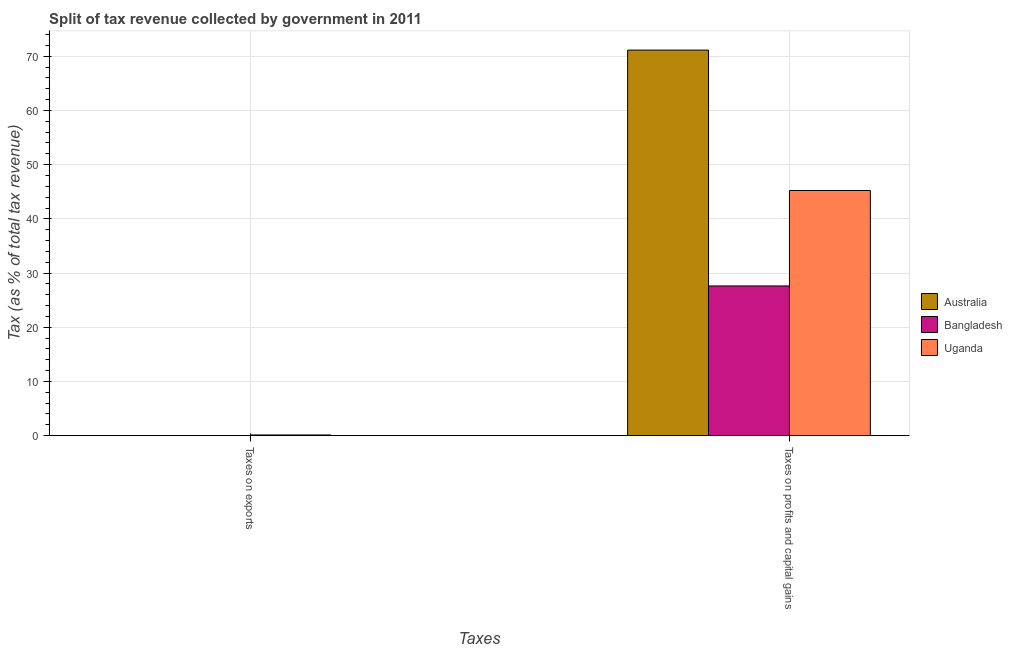How many groups of bars are there?
Give a very brief answer. 2. Are the number of bars on each tick of the X-axis equal?
Give a very brief answer. Yes. What is the label of the 2nd group of bars from the left?
Your answer should be very brief. Taxes on profits and capital gains. What is the percentage of revenue obtained from taxes on profits and capital gains in Uganda?
Your answer should be compact. 45.24. Across all countries, what is the maximum percentage of revenue obtained from taxes on profits and capital gains?
Offer a very short reply. 71.14. Across all countries, what is the minimum percentage of revenue obtained from taxes on profits and capital gains?
Make the answer very short. 27.62. In which country was the percentage of revenue obtained from taxes on profits and capital gains minimum?
Make the answer very short. Bangladesh. What is the total percentage of revenue obtained from taxes on profits and capital gains in the graph?
Offer a terse response. 143.99. What is the difference between the percentage of revenue obtained from taxes on profits and capital gains in Australia and that in Uganda?
Offer a terse response. 25.9. What is the difference between the percentage of revenue obtained from taxes on profits and capital gains in Uganda and the percentage of revenue obtained from taxes on exports in Bangladesh?
Keep it short and to the point. 45.24. What is the average percentage of revenue obtained from taxes on profits and capital gains per country?
Offer a terse response. 48. What is the difference between the percentage of revenue obtained from taxes on profits and capital gains and percentage of revenue obtained from taxes on exports in Australia?
Provide a short and direct response. 71.13. In how many countries, is the percentage of revenue obtained from taxes on profits and capital gains greater than 22 %?
Ensure brevity in your answer.  3. What is the ratio of the percentage of revenue obtained from taxes on exports in Bangladesh to that in Australia?
Offer a very short reply. 0. What does the 3rd bar from the left in Taxes on profits and capital gains represents?
Give a very brief answer. Uganda. What does the 1st bar from the right in Taxes on profits and capital gains represents?
Make the answer very short. Uganda. Are all the bars in the graph horizontal?
Offer a terse response. No. How many countries are there in the graph?
Your answer should be compact. 3. Are the values on the major ticks of Y-axis written in scientific E-notation?
Make the answer very short. No. Does the graph contain grids?
Ensure brevity in your answer.  Yes. Where does the legend appear in the graph?
Your answer should be very brief. Center right. How many legend labels are there?
Offer a terse response. 3. How are the legend labels stacked?
Your answer should be very brief. Vertical. What is the title of the graph?
Provide a succinct answer. Split of tax revenue collected by government in 2011. Does "Nigeria" appear as one of the legend labels in the graph?
Offer a very short reply. No. What is the label or title of the X-axis?
Offer a terse response. Taxes. What is the label or title of the Y-axis?
Your answer should be compact. Tax (as % of total tax revenue). What is the Tax (as % of total tax revenue) of Australia in Taxes on exports?
Provide a short and direct response. 0. What is the Tax (as % of total tax revenue) in Bangladesh in Taxes on exports?
Provide a succinct answer. 1.00567926439932e-6. What is the Tax (as % of total tax revenue) in Uganda in Taxes on exports?
Your response must be concise. 0.13. What is the Tax (as % of total tax revenue) in Australia in Taxes on profits and capital gains?
Make the answer very short. 71.14. What is the Tax (as % of total tax revenue) in Bangladesh in Taxes on profits and capital gains?
Keep it short and to the point. 27.62. What is the Tax (as % of total tax revenue) of Uganda in Taxes on profits and capital gains?
Provide a succinct answer. 45.24. Across all Taxes, what is the maximum Tax (as % of total tax revenue) in Australia?
Give a very brief answer. 71.14. Across all Taxes, what is the maximum Tax (as % of total tax revenue) of Bangladesh?
Your response must be concise. 27.62. Across all Taxes, what is the maximum Tax (as % of total tax revenue) in Uganda?
Keep it short and to the point. 45.24. Across all Taxes, what is the minimum Tax (as % of total tax revenue) in Australia?
Provide a succinct answer. 0. Across all Taxes, what is the minimum Tax (as % of total tax revenue) in Bangladesh?
Ensure brevity in your answer.  1.00567926439932e-6. Across all Taxes, what is the minimum Tax (as % of total tax revenue) in Uganda?
Your answer should be very brief. 0.13. What is the total Tax (as % of total tax revenue) in Australia in the graph?
Your answer should be very brief. 71.14. What is the total Tax (as % of total tax revenue) of Bangladesh in the graph?
Ensure brevity in your answer.  27.62. What is the total Tax (as % of total tax revenue) in Uganda in the graph?
Your answer should be very brief. 45.36. What is the difference between the Tax (as % of total tax revenue) in Australia in Taxes on exports and that in Taxes on profits and capital gains?
Make the answer very short. -71.13. What is the difference between the Tax (as % of total tax revenue) in Bangladesh in Taxes on exports and that in Taxes on profits and capital gains?
Offer a terse response. -27.62. What is the difference between the Tax (as % of total tax revenue) in Uganda in Taxes on exports and that in Taxes on profits and capital gains?
Offer a terse response. -45.11. What is the difference between the Tax (as % of total tax revenue) of Australia in Taxes on exports and the Tax (as % of total tax revenue) of Bangladesh in Taxes on profits and capital gains?
Give a very brief answer. -27.62. What is the difference between the Tax (as % of total tax revenue) of Australia in Taxes on exports and the Tax (as % of total tax revenue) of Uganda in Taxes on profits and capital gains?
Your response must be concise. -45.23. What is the difference between the Tax (as % of total tax revenue) in Bangladesh in Taxes on exports and the Tax (as % of total tax revenue) in Uganda in Taxes on profits and capital gains?
Offer a very short reply. -45.24. What is the average Tax (as % of total tax revenue) in Australia per Taxes?
Provide a succinct answer. 35.57. What is the average Tax (as % of total tax revenue) in Bangladesh per Taxes?
Provide a succinct answer. 13.81. What is the average Tax (as % of total tax revenue) of Uganda per Taxes?
Give a very brief answer. 22.68. What is the difference between the Tax (as % of total tax revenue) in Australia and Tax (as % of total tax revenue) in Bangladesh in Taxes on exports?
Your answer should be very brief. 0. What is the difference between the Tax (as % of total tax revenue) in Australia and Tax (as % of total tax revenue) in Uganda in Taxes on exports?
Your answer should be very brief. -0.12. What is the difference between the Tax (as % of total tax revenue) in Bangladesh and Tax (as % of total tax revenue) in Uganda in Taxes on exports?
Keep it short and to the point. -0.13. What is the difference between the Tax (as % of total tax revenue) in Australia and Tax (as % of total tax revenue) in Bangladesh in Taxes on profits and capital gains?
Your answer should be very brief. 43.52. What is the difference between the Tax (as % of total tax revenue) in Australia and Tax (as % of total tax revenue) in Uganda in Taxes on profits and capital gains?
Offer a very short reply. 25.9. What is the difference between the Tax (as % of total tax revenue) in Bangladesh and Tax (as % of total tax revenue) in Uganda in Taxes on profits and capital gains?
Offer a very short reply. -17.62. What is the ratio of the Tax (as % of total tax revenue) of Bangladesh in Taxes on exports to that in Taxes on profits and capital gains?
Offer a terse response. 0. What is the ratio of the Tax (as % of total tax revenue) of Uganda in Taxes on exports to that in Taxes on profits and capital gains?
Provide a succinct answer. 0. What is the difference between the highest and the second highest Tax (as % of total tax revenue) of Australia?
Ensure brevity in your answer.  71.13. What is the difference between the highest and the second highest Tax (as % of total tax revenue) of Bangladesh?
Your answer should be very brief. 27.62. What is the difference between the highest and the second highest Tax (as % of total tax revenue) in Uganda?
Your response must be concise. 45.11. What is the difference between the highest and the lowest Tax (as % of total tax revenue) of Australia?
Your answer should be very brief. 71.13. What is the difference between the highest and the lowest Tax (as % of total tax revenue) in Bangladesh?
Make the answer very short. 27.62. What is the difference between the highest and the lowest Tax (as % of total tax revenue) of Uganda?
Make the answer very short. 45.11. 